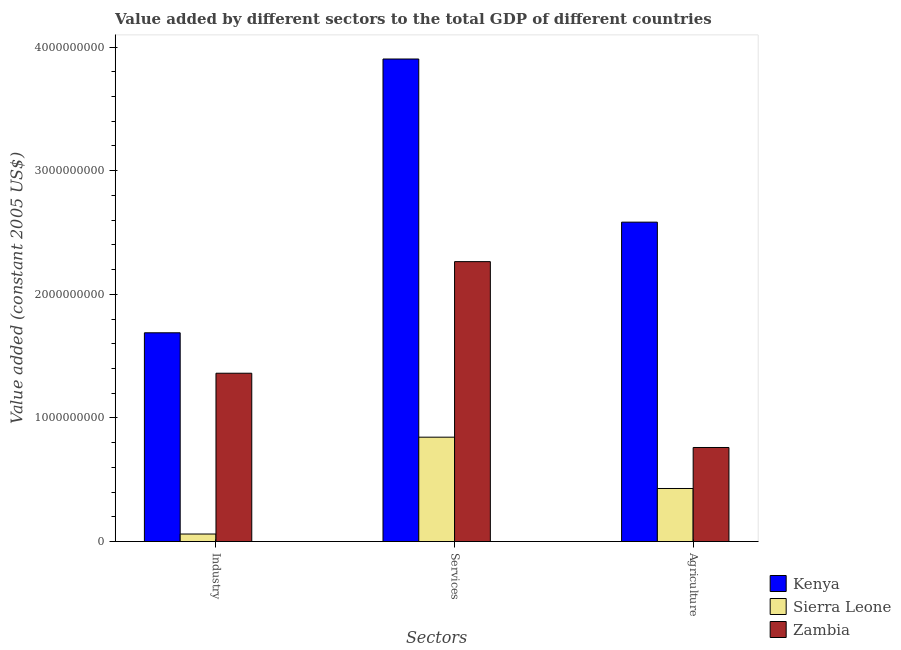How many different coloured bars are there?
Offer a terse response. 3. How many groups of bars are there?
Provide a short and direct response. 3. Are the number of bars on each tick of the X-axis equal?
Offer a very short reply. Yes. How many bars are there on the 3rd tick from the left?
Your answer should be compact. 3. What is the label of the 1st group of bars from the left?
Make the answer very short. Industry. What is the value added by services in Kenya?
Your answer should be compact. 3.90e+09. Across all countries, what is the maximum value added by services?
Make the answer very short. 3.90e+09. Across all countries, what is the minimum value added by agricultural sector?
Make the answer very short. 4.29e+08. In which country was the value added by industrial sector maximum?
Your answer should be compact. Kenya. In which country was the value added by services minimum?
Make the answer very short. Sierra Leone. What is the total value added by services in the graph?
Make the answer very short. 7.01e+09. What is the difference between the value added by services in Sierra Leone and that in Kenya?
Offer a terse response. -3.06e+09. What is the difference between the value added by agricultural sector in Sierra Leone and the value added by services in Zambia?
Keep it short and to the point. -1.83e+09. What is the average value added by services per country?
Make the answer very short. 2.34e+09. What is the difference between the value added by agricultural sector and value added by services in Kenya?
Offer a very short reply. -1.32e+09. In how many countries, is the value added by industrial sector greater than 3600000000 US$?
Provide a short and direct response. 0. What is the ratio of the value added by industrial sector in Zambia to that in Kenya?
Offer a very short reply. 0.81. Is the value added by services in Zambia less than that in Sierra Leone?
Offer a very short reply. No. What is the difference between the highest and the second highest value added by services?
Offer a very short reply. 1.64e+09. What is the difference between the highest and the lowest value added by agricultural sector?
Your answer should be very brief. 2.15e+09. In how many countries, is the value added by services greater than the average value added by services taken over all countries?
Provide a short and direct response. 1. Is the sum of the value added by agricultural sector in Sierra Leone and Kenya greater than the maximum value added by industrial sector across all countries?
Ensure brevity in your answer.  Yes. What does the 1st bar from the left in Services represents?
Offer a terse response. Kenya. What does the 3rd bar from the right in Industry represents?
Ensure brevity in your answer.  Kenya. Is it the case that in every country, the sum of the value added by industrial sector and value added by services is greater than the value added by agricultural sector?
Ensure brevity in your answer.  Yes. Are all the bars in the graph horizontal?
Give a very brief answer. No. How many countries are there in the graph?
Make the answer very short. 3. Are the values on the major ticks of Y-axis written in scientific E-notation?
Provide a succinct answer. No. How are the legend labels stacked?
Keep it short and to the point. Vertical. What is the title of the graph?
Keep it short and to the point. Value added by different sectors to the total GDP of different countries. Does "Eritrea" appear as one of the legend labels in the graph?
Your answer should be compact. No. What is the label or title of the X-axis?
Make the answer very short. Sectors. What is the label or title of the Y-axis?
Provide a succinct answer. Value added (constant 2005 US$). What is the Value added (constant 2005 US$) in Kenya in Industry?
Give a very brief answer. 1.69e+09. What is the Value added (constant 2005 US$) in Sierra Leone in Industry?
Provide a short and direct response. 6.10e+07. What is the Value added (constant 2005 US$) in Zambia in Industry?
Make the answer very short. 1.36e+09. What is the Value added (constant 2005 US$) of Kenya in Services?
Ensure brevity in your answer.  3.90e+09. What is the Value added (constant 2005 US$) in Sierra Leone in Services?
Provide a succinct answer. 8.44e+08. What is the Value added (constant 2005 US$) in Zambia in Services?
Give a very brief answer. 2.26e+09. What is the Value added (constant 2005 US$) of Kenya in Agriculture?
Give a very brief answer. 2.58e+09. What is the Value added (constant 2005 US$) of Sierra Leone in Agriculture?
Make the answer very short. 4.29e+08. What is the Value added (constant 2005 US$) of Zambia in Agriculture?
Offer a very short reply. 7.61e+08. Across all Sectors, what is the maximum Value added (constant 2005 US$) in Kenya?
Offer a very short reply. 3.90e+09. Across all Sectors, what is the maximum Value added (constant 2005 US$) of Sierra Leone?
Your answer should be very brief. 8.44e+08. Across all Sectors, what is the maximum Value added (constant 2005 US$) of Zambia?
Your answer should be very brief. 2.26e+09. Across all Sectors, what is the minimum Value added (constant 2005 US$) in Kenya?
Give a very brief answer. 1.69e+09. Across all Sectors, what is the minimum Value added (constant 2005 US$) of Sierra Leone?
Your response must be concise. 6.10e+07. Across all Sectors, what is the minimum Value added (constant 2005 US$) in Zambia?
Provide a short and direct response. 7.61e+08. What is the total Value added (constant 2005 US$) in Kenya in the graph?
Offer a terse response. 8.18e+09. What is the total Value added (constant 2005 US$) in Sierra Leone in the graph?
Provide a succinct answer. 1.33e+09. What is the total Value added (constant 2005 US$) of Zambia in the graph?
Provide a succinct answer. 4.39e+09. What is the difference between the Value added (constant 2005 US$) of Kenya in Industry and that in Services?
Provide a succinct answer. -2.21e+09. What is the difference between the Value added (constant 2005 US$) in Sierra Leone in Industry and that in Services?
Give a very brief answer. -7.83e+08. What is the difference between the Value added (constant 2005 US$) of Zambia in Industry and that in Services?
Provide a short and direct response. -9.03e+08. What is the difference between the Value added (constant 2005 US$) in Kenya in Industry and that in Agriculture?
Ensure brevity in your answer.  -8.95e+08. What is the difference between the Value added (constant 2005 US$) of Sierra Leone in Industry and that in Agriculture?
Make the answer very short. -3.68e+08. What is the difference between the Value added (constant 2005 US$) of Zambia in Industry and that in Agriculture?
Give a very brief answer. 6.01e+08. What is the difference between the Value added (constant 2005 US$) of Kenya in Services and that in Agriculture?
Offer a very short reply. 1.32e+09. What is the difference between the Value added (constant 2005 US$) in Sierra Leone in Services and that in Agriculture?
Provide a short and direct response. 4.15e+08. What is the difference between the Value added (constant 2005 US$) of Zambia in Services and that in Agriculture?
Your answer should be compact. 1.50e+09. What is the difference between the Value added (constant 2005 US$) of Kenya in Industry and the Value added (constant 2005 US$) of Sierra Leone in Services?
Ensure brevity in your answer.  8.44e+08. What is the difference between the Value added (constant 2005 US$) in Kenya in Industry and the Value added (constant 2005 US$) in Zambia in Services?
Provide a succinct answer. -5.76e+08. What is the difference between the Value added (constant 2005 US$) in Sierra Leone in Industry and the Value added (constant 2005 US$) in Zambia in Services?
Ensure brevity in your answer.  -2.20e+09. What is the difference between the Value added (constant 2005 US$) of Kenya in Industry and the Value added (constant 2005 US$) of Sierra Leone in Agriculture?
Your response must be concise. 1.26e+09. What is the difference between the Value added (constant 2005 US$) in Kenya in Industry and the Value added (constant 2005 US$) in Zambia in Agriculture?
Your answer should be very brief. 9.28e+08. What is the difference between the Value added (constant 2005 US$) of Sierra Leone in Industry and the Value added (constant 2005 US$) of Zambia in Agriculture?
Offer a terse response. -7.00e+08. What is the difference between the Value added (constant 2005 US$) in Kenya in Services and the Value added (constant 2005 US$) in Sierra Leone in Agriculture?
Your response must be concise. 3.47e+09. What is the difference between the Value added (constant 2005 US$) of Kenya in Services and the Value added (constant 2005 US$) of Zambia in Agriculture?
Ensure brevity in your answer.  3.14e+09. What is the difference between the Value added (constant 2005 US$) of Sierra Leone in Services and the Value added (constant 2005 US$) of Zambia in Agriculture?
Offer a very short reply. 8.34e+07. What is the average Value added (constant 2005 US$) of Kenya per Sectors?
Give a very brief answer. 2.73e+09. What is the average Value added (constant 2005 US$) in Sierra Leone per Sectors?
Provide a short and direct response. 4.45e+08. What is the average Value added (constant 2005 US$) in Zambia per Sectors?
Ensure brevity in your answer.  1.46e+09. What is the difference between the Value added (constant 2005 US$) of Kenya and Value added (constant 2005 US$) of Sierra Leone in Industry?
Provide a succinct answer. 1.63e+09. What is the difference between the Value added (constant 2005 US$) of Kenya and Value added (constant 2005 US$) of Zambia in Industry?
Your response must be concise. 3.27e+08. What is the difference between the Value added (constant 2005 US$) in Sierra Leone and Value added (constant 2005 US$) in Zambia in Industry?
Provide a succinct answer. -1.30e+09. What is the difference between the Value added (constant 2005 US$) of Kenya and Value added (constant 2005 US$) of Sierra Leone in Services?
Give a very brief answer. 3.06e+09. What is the difference between the Value added (constant 2005 US$) in Kenya and Value added (constant 2005 US$) in Zambia in Services?
Offer a terse response. 1.64e+09. What is the difference between the Value added (constant 2005 US$) of Sierra Leone and Value added (constant 2005 US$) of Zambia in Services?
Your response must be concise. -1.42e+09. What is the difference between the Value added (constant 2005 US$) of Kenya and Value added (constant 2005 US$) of Sierra Leone in Agriculture?
Provide a succinct answer. 2.15e+09. What is the difference between the Value added (constant 2005 US$) in Kenya and Value added (constant 2005 US$) in Zambia in Agriculture?
Keep it short and to the point. 1.82e+09. What is the difference between the Value added (constant 2005 US$) of Sierra Leone and Value added (constant 2005 US$) of Zambia in Agriculture?
Offer a very short reply. -3.32e+08. What is the ratio of the Value added (constant 2005 US$) in Kenya in Industry to that in Services?
Provide a succinct answer. 0.43. What is the ratio of the Value added (constant 2005 US$) of Sierra Leone in Industry to that in Services?
Offer a terse response. 0.07. What is the ratio of the Value added (constant 2005 US$) of Zambia in Industry to that in Services?
Offer a terse response. 0.6. What is the ratio of the Value added (constant 2005 US$) of Kenya in Industry to that in Agriculture?
Ensure brevity in your answer.  0.65. What is the ratio of the Value added (constant 2005 US$) in Sierra Leone in Industry to that in Agriculture?
Provide a succinct answer. 0.14. What is the ratio of the Value added (constant 2005 US$) of Zambia in Industry to that in Agriculture?
Offer a very short reply. 1.79. What is the ratio of the Value added (constant 2005 US$) in Kenya in Services to that in Agriculture?
Ensure brevity in your answer.  1.51. What is the ratio of the Value added (constant 2005 US$) of Sierra Leone in Services to that in Agriculture?
Your response must be concise. 1.97. What is the ratio of the Value added (constant 2005 US$) of Zambia in Services to that in Agriculture?
Provide a short and direct response. 2.98. What is the difference between the highest and the second highest Value added (constant 2005 US$) of Kenya?
Make the answer very short. 1.32e+09. What is the difference between the highest and the second highest Value added (constant 2005 US$) in Sierra Leone?
Provide a succinct answer. 4.15e+08. What is the difference between the highest and the second highest Value added (constant 2005 US$) of Zambia?
Your answer should be very brief. 9.03e+08. What is the difference between the highest and the lowest Value added (constant 2005 US$) in Kenya?
Offer a terse response. 2.21e+09. What is the difference between the highest and the lowest Value added (constant 2005 US$) of Sierra Leone?
Your answer should be compact. 7.83e+08. What is the difference between the highest and the lowest Value added (constant 2005 US$) of Zambia?
Your answer should be compact. 1.50e+09. 